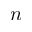Convert formula to latex. <formula><loc_0><loc_0><loc_500><loc_500>n</formula> 